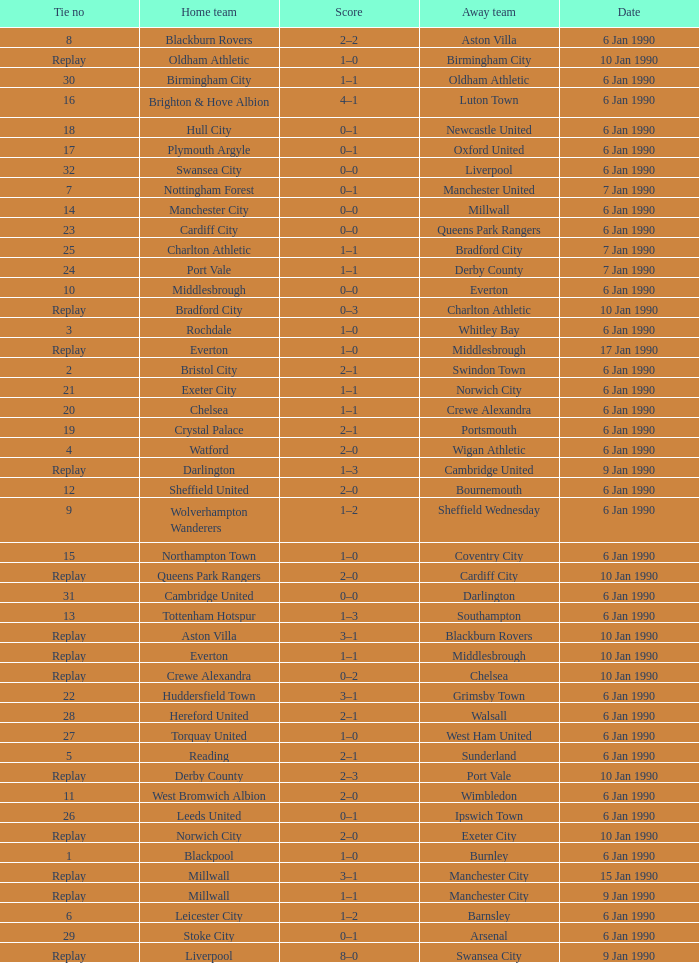What was the score of the game against away team crewe alexandra? 1–1. 